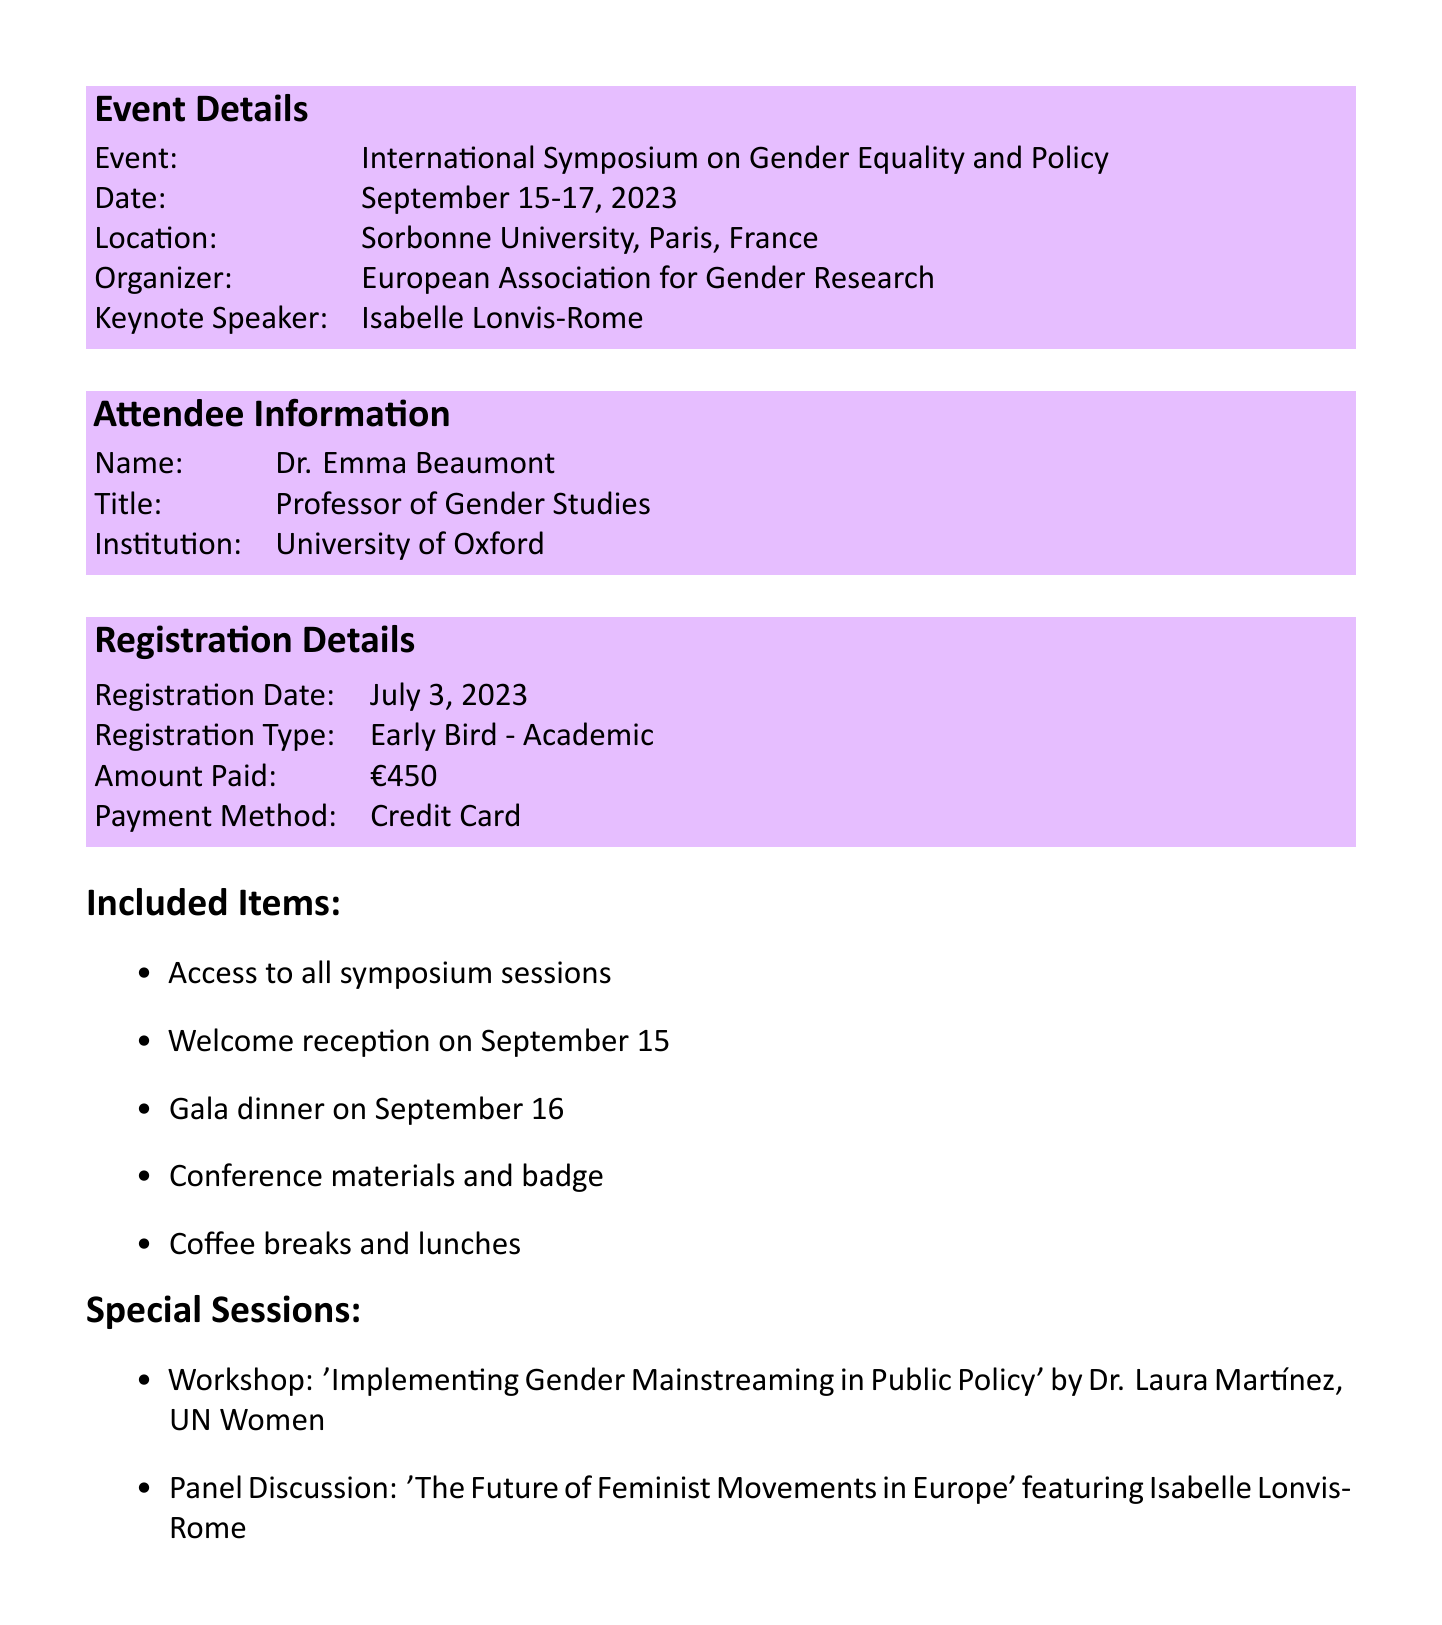what is the event name? The event name is specified in the details section of the document.
Answer: International Symposium on Gender Equality and Policy who is the keynote speaker? The keynote speaker's name is listed under event details in the document.
Answer: Isabelle Lonvis-Rome when was the registration date? The registration date can be found in the registration details section.
Answer: July 3, 2023 how much did Dr. Emma Beaumont pay for registration? The amount paid is clearly indicated in the registration details portion of the document.
Answer: €450 what is the location of the symposium? The location is mentioned in the event details section of the document.
Answer: Sorbonne University, Paris, France what type of registration was made? The type of registration is provided in the registration details section.
Answer: Early Bird - Academic what is one special session listed in the document? The document includes a section detailing special sessions available at the symposium.
Answer: Workshop: 'Implementing Gender Mainstreaming in Public Policy' by Dr. Laura Martínez, UN Women who organized the event? The organizer's name is mentioned in the event details section of the document.
Answer: European Association for Gender Research what should attendees bring for check-in? The additional notes section specifies what attendees should bring.
Answer: ID and this receipt 